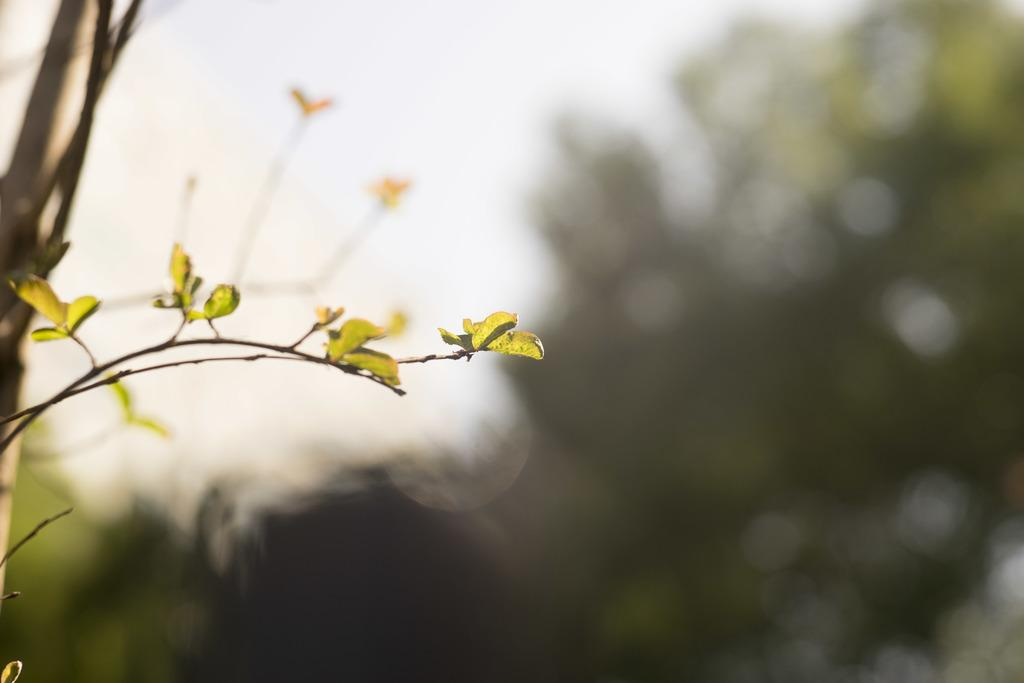What is located towards the left side of the image? There is a tree truncated towards the left of the image. What can be seen in the background of the image? The sky is visible in the image. How would you describe the background of the image? The background of the image is blurred. What word is written on the rock in the image? There is no rock or word present in the image. 